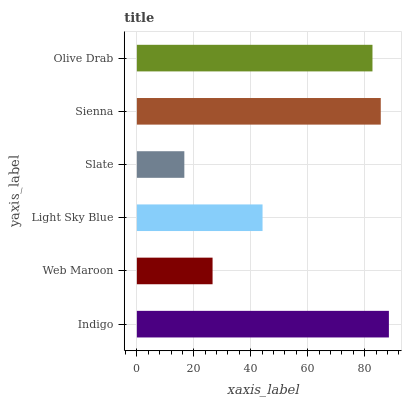Is Slate the minimum?
Answer yes or no. Yes. Is Indigo the maximum?
Answer yes or no. Yes. Is Web Maroon the minimum?
Answer yes or no. No. Is Web Maroon the maximum?
Answer yes or no. No. Is Indigo greater than Web Maroon?
Answer yes or no. Yes. Is Web Maroon less than Indigo?
Answer yes or no. Yes. Is Web Maroon greater than Indigo?
Answer yes or no. No. Is Indigo less than Web Maroon?
Answer yes or no. No. Is Olive Drab the high median?
Answer yes or no. Yes. Is Light Sky Blue the low median?
Answer yes or no. Yes. Is Slate the high median?
Answer yes or no. No. Is Slate the low median?
Answer yes or no. No. 